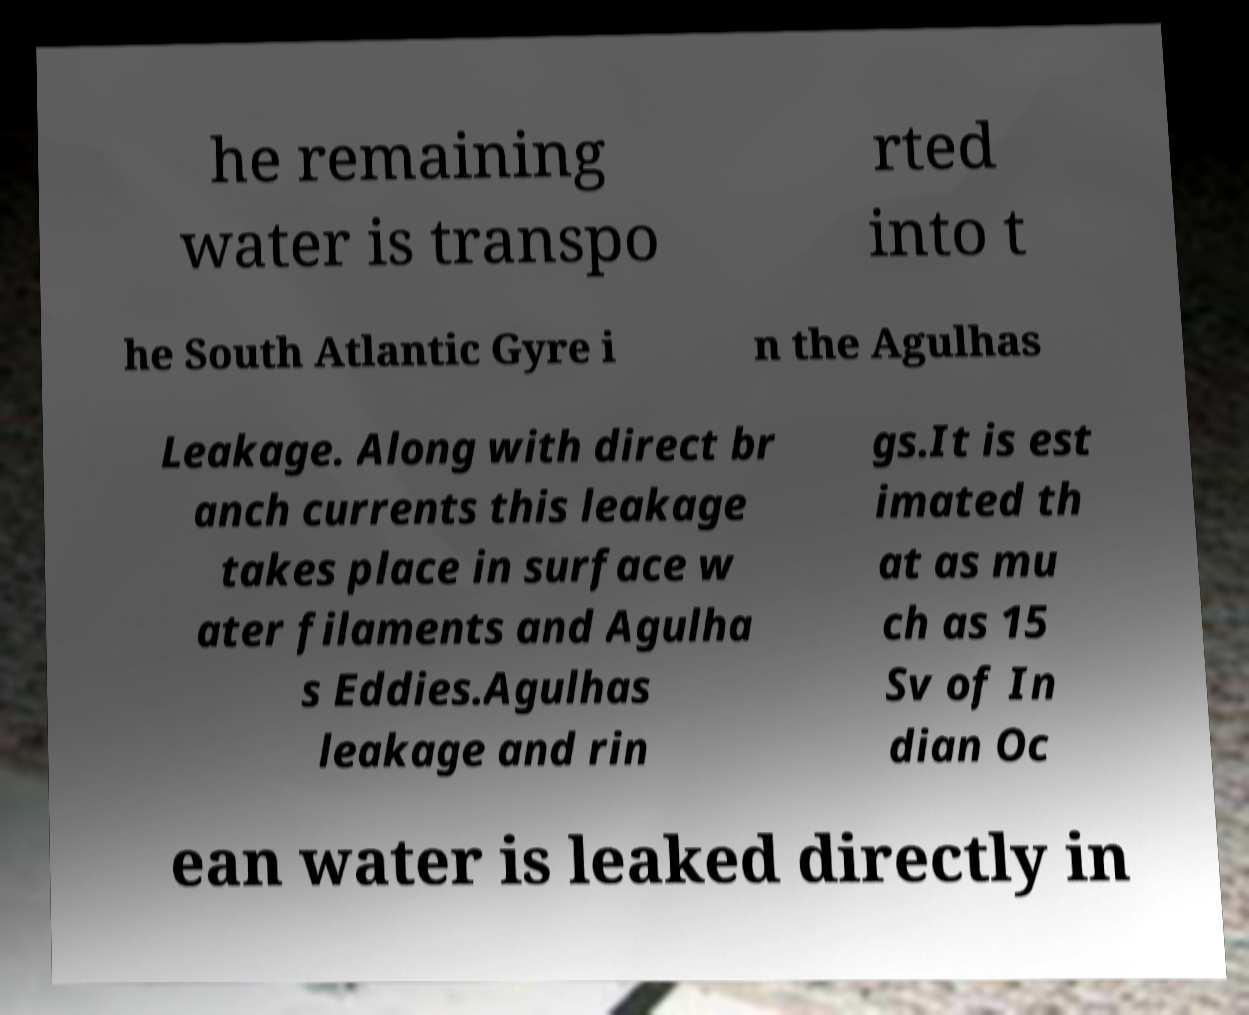For documentation purposes, I need the text within this image transcribed. Could you provide that? he remaining water is transpo rted into t he South Atlantic Gyre i n the Agulhas Leakage. Along with direct br anch currents this leakage takes place in surface w ater filaments and Agulha s Eddies.Agulhas leakage and rin gs.It is est imated th at as mu ch as 15 Sv of In dian Oc ean water is leaked directly in 